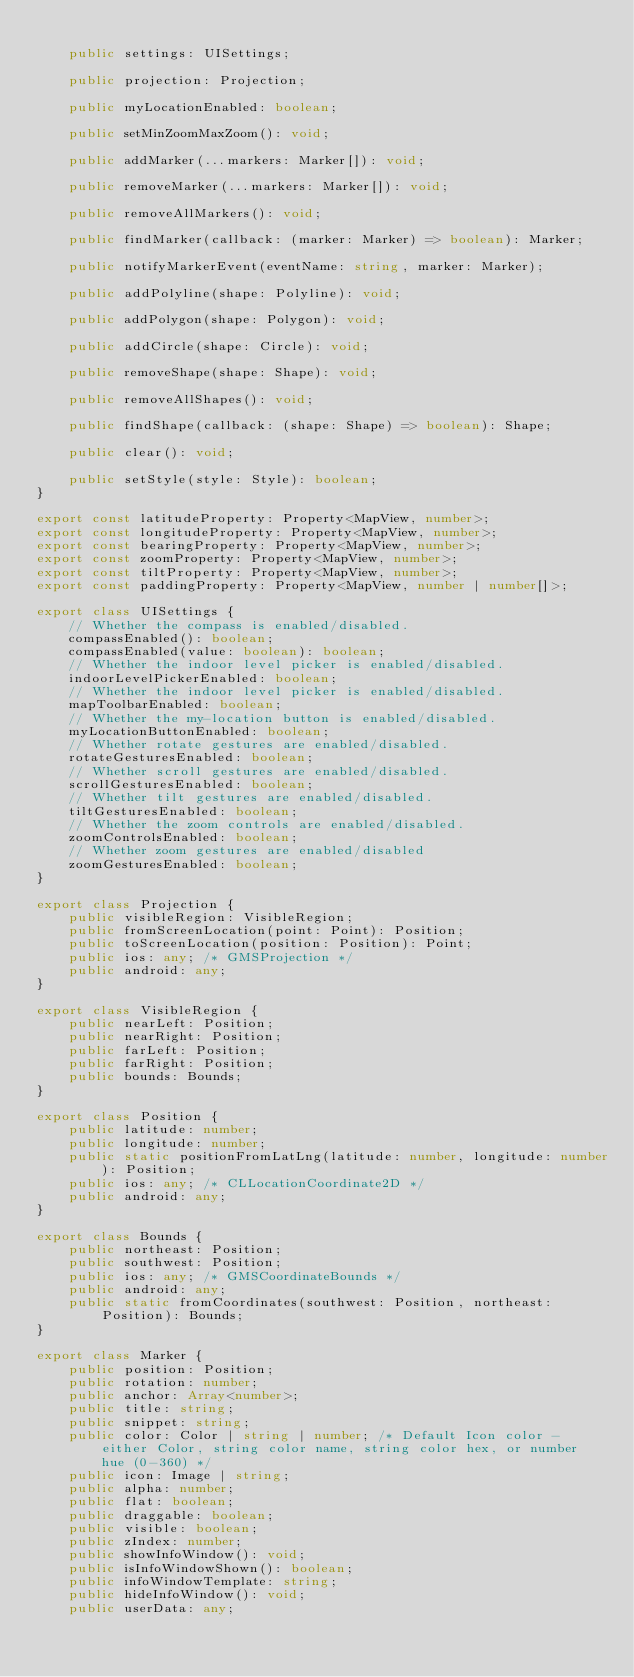<code> <loc_0><loc_0><loc_500><loc_500><_TypeScript_>
    public settings: UISettings;

    public projection: Projection;

    public myLocationEnabled: boolean;

    public setMinZoomMaxZoom(): void;

    public addMarker(...markers: Marker[]): void;

    public removeMarker(...markers: Marker[]): void;

    public removeAllMarkers(): void;

    public findMarker(callback: (marker: Marker) => boolean): Marker;

    public notifyMarkerEvent(eventName: string, marker: Marker);

    public addPolyline(shape: Polyline): void;

    public addPolygon(shape: Polygon): void;

    public addCircle(shape: Circle): void;

    public removeShape(shape: Shape): void;

    public removeAllShapes(): void;

    public findShape(callback: (shape: Shape) => boolean): Shape;

    public clear(): void;

    public setStyle(style: Style): boolean;
}

export const latitudeProperty: Property<MapView, number>;
export const longitudeProperty: Property<MapView, number>;
export const bearingProperty: Property<MapView, number>;
export const zoomProperty: Property<MapView, number>;
export const tiltProperty: Property<MapView, number>;
export const paddingProperty: Property<MapView, number | number[]>;

export class UISettings {
    // Whether the compass is enabled/disabled.
    compassEnabled(): boolean;
    compassEnabled(value: boolean): boolean;
    // Whether the indoor level picker is enabled/disabled.
    indoorLevelPickerEnabled: boolean;
    // Whether the indoor level picker is enabled/disabled.
    mapToolbarEnabled: boolean;
    // Whether the my-location button is enabled/disabled.
    myLocationButtonEnabled: boolean;
    // Whether rotate gestures are enabled/disabled.
    rotateGesturesEnabled: boolean;
    // Whether scroll gestures are enabled/disabled.
    scrollGesturesEnabled: boolean;
    // Whether tilt gestures are enabled/disabled.
    tiltGesturesEnabled: boolean;
    // Whether the zoom controls are enabled/disabled.
    zoomControlsEnabled: boolean;
    // Whether zoom gestures are enabled/disabled
    zoomGesturesEnabled: boolean;
}

export class Projection {
    public visibleRegion: VisibleRegion;
    public fromScreenLocation(point: Point): Position;
    public toScreenLocation(position: Position): Point;
    public ios: any; /* GMSProjection */
    public android: any;
}

export class VisibleRegion {
    public nearLeft: Position;
    public nearRight: Position;
    public farLeft: Position;
    public farRight: Position;
    public bounds: Bounds;
}

export class Position {
    public latitude: number;
    public longitude: number;
    public static positionFromLatLng(latitude: number, longitude: number): Position;
    public ios: any; /* CLLocationCoordinate2D */
    public android: any;
}

export class Bounds {
    public northeast: Position;
    public southwest: Position;
    public ios: any; /* GMSCoordinateBounds */
    public android: any;
    public static fromCoordinates(southwest: Position, northeast: Position): Bounds;
}

export class Marker {
    public position: Position;
    public rotation: number;
    public anchor: Array<number>;
    public title: string;
    public snippet: string;
    public color: Color | string | number; /* Default Icon color - either Color, string color name, string color hex, or number hue (0-360) */
    public icon: Image | string;
    public alpha: number;
    public flat: boolean;
    public draggable: boolean;
    public visible: boolean;
    public zIndex: number;
    public showInfoWindow(): void;
    public isInfoWindowShown(): boolean;
    public infoWindowTemplate: string;
    public hideInfoWindow(): void;
    public userData: any;</code> 